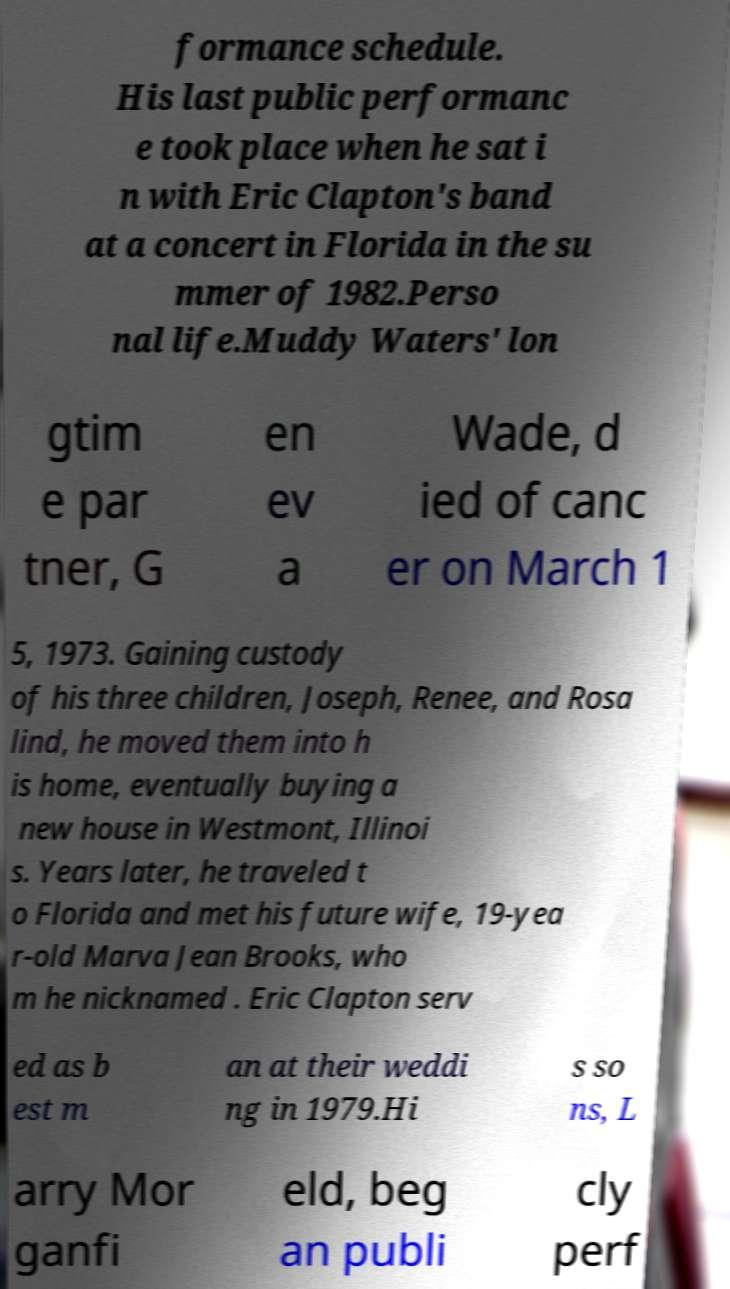Please identify and transcribe the text found in this image. formance schedule. His last public performanc e took place when he sat i n with Eric Clapton's band at a concert in Florida in the su mmer of 1982.Perso nal life.Muddy Waters' lon gtim e par tner, G en ev a Wade, d ied of canc er on March 1 5, 1973. Gaining custody of his three children, Joseph, Renee, and Rosa lind, he moved them into h is home, eventually buying a new house in Westmont, Illinoi s. Years later, he traveled t o Florida and met his future wife, 19-yea r-old Marva Jean Brooks, who m he nicknamed . Eric Clapton serv ed as b est m an at their weddi ng in 1979.Hi s so ns, L arry Mor ganfi eld, beg an publi cly perf 